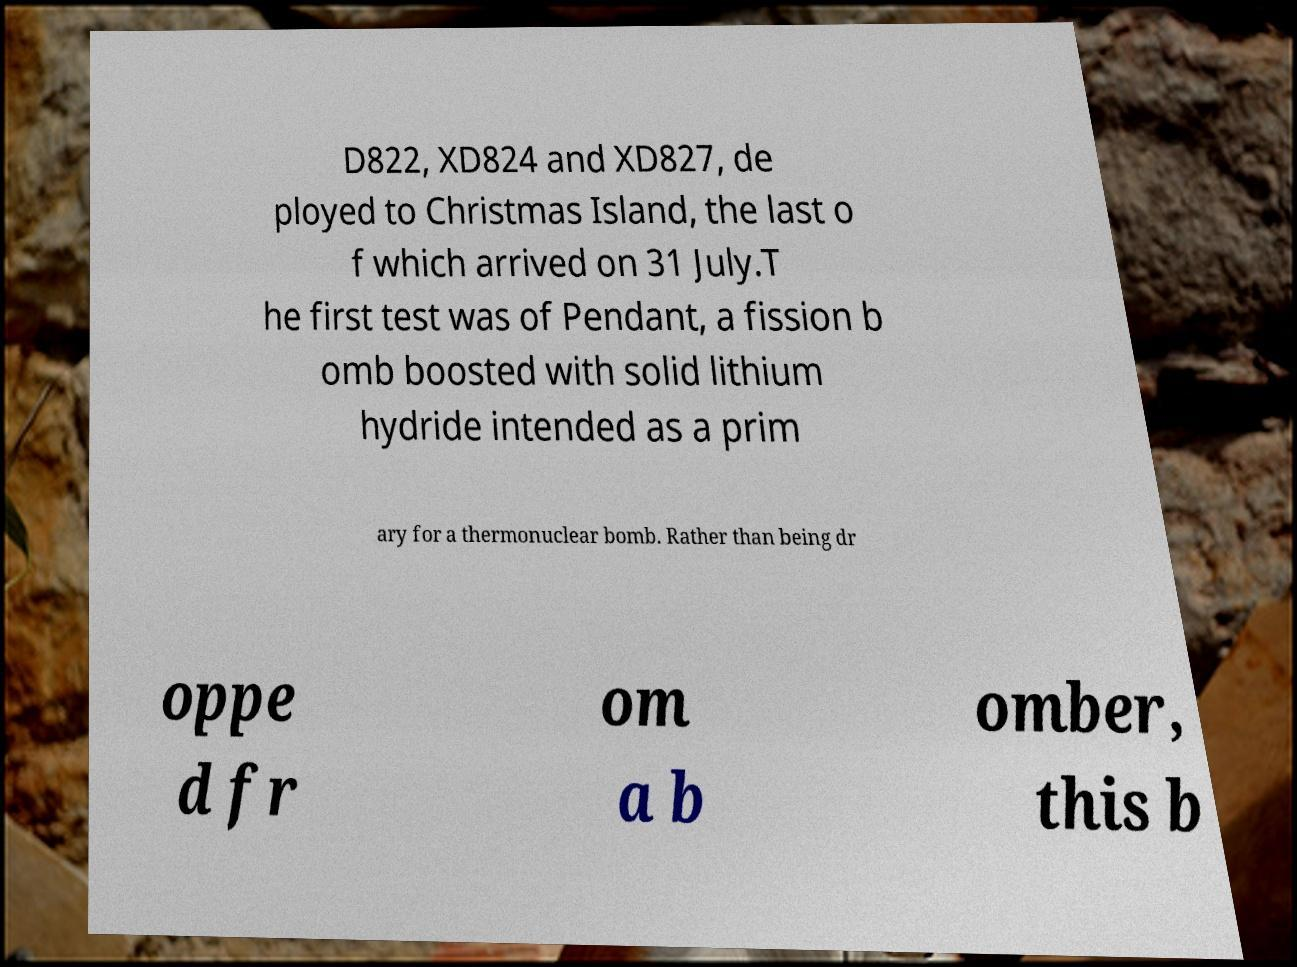There's text embedded in this image that I need extracted. Can you transcribe it verbatim? D822, XD824 and XD827, de ployed to Christmas Island, the last o f which arrived on 31 July.T he first test was of Pendant, a fission b omb boosted with solid lithium hydride intended as a prim ary for a thermonuclear bomb. Rather than being dr oppe d fr om a b omber, this b 